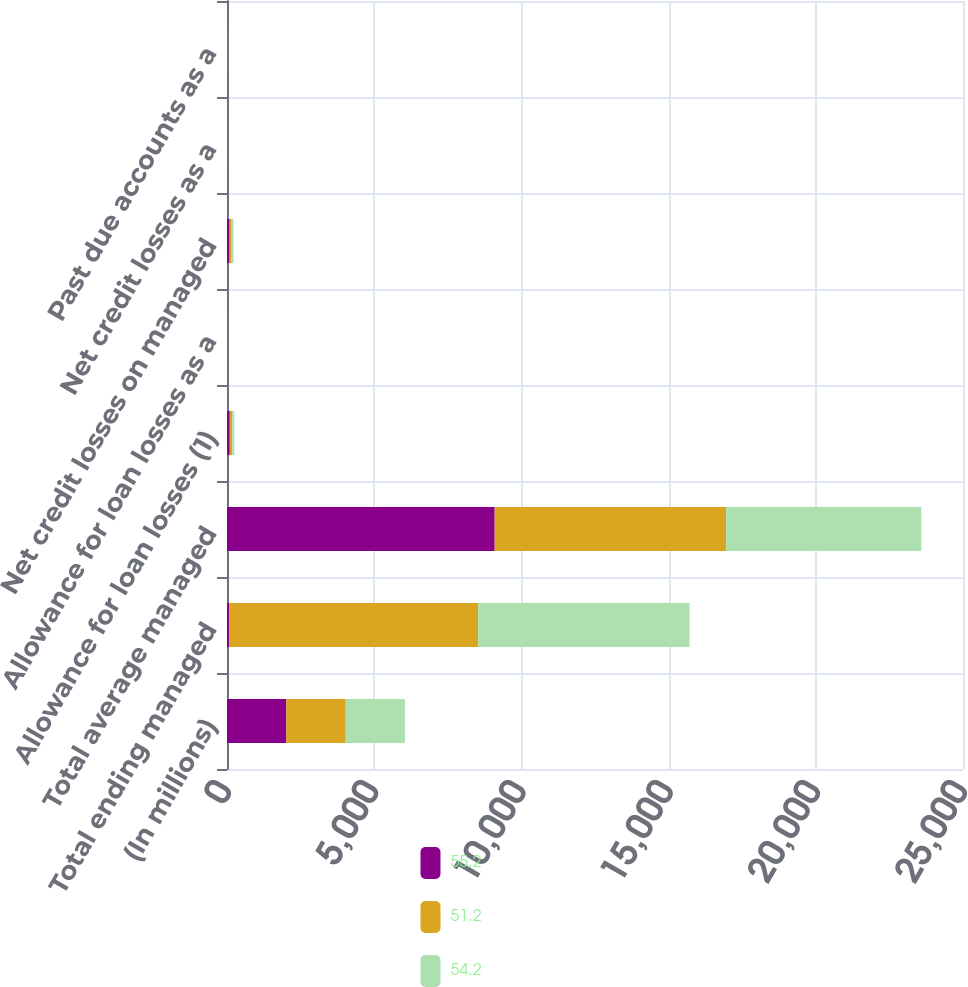Convert chart. <chart><loc_0><loc_0><loc_500><loc_500><stacked_bar_chart><ecel><fcel>(In millions)<fcel>Total ending managed<fcel>Total average managed<fcel>Allowance for loan losses (1)<fcel>Allowance for loan losses as a<fcel>Net credit losses on managed<fcel>Net credit losses as a<fcel>Past due accounts as a<nl><fcel>55.2<fcel>2016<fcel>70.5<fcel>9092.9<fcel>94.9<fcel>0.99<fcel>88<fcel>0.97<fcel>2.74<nl><fcel>51.2<fcel>2015<fcel>8458.7<fcel>7859.9<fcel>81.7<fcel>0.97<fcel>70.5<fcel>0.9<fcel>2.62<nl><fcel>54.2<fcel>2014<fcel>7184.4<fcel>6629.5<fcel>69.9<fcel>0.97<fcel>59.6<fcel>0.9<fcel>2.58<nl></chart> 